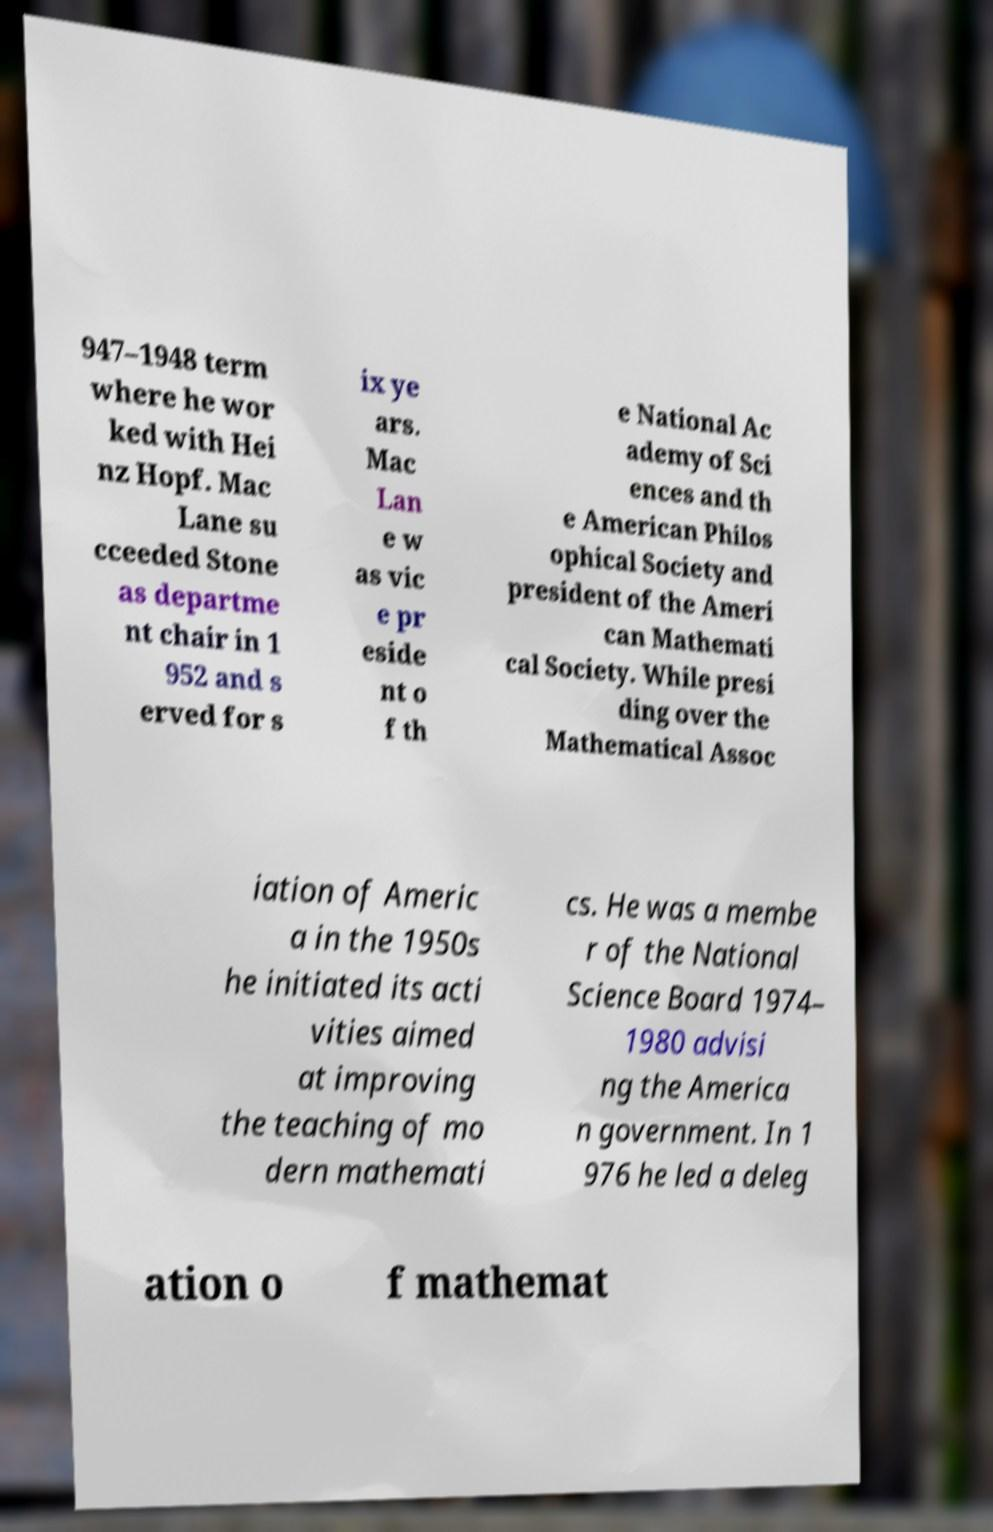There's text embedded in this image that I need extracted. Can you transcribe it verbatim? 947–1948 term where he wor ked with Hei nz Hopf. Mac Lane su cceeded Stone as departme nt chair in 1 952 and s erved for s ix ye ars. Mac Lan e w as vic e pr eside nt o f th e National Ac ademy of Sci ences and th e American Philos ophical Society and president of the Ameri can Mathemati cal Society. While presi ding over the Mathematical Assoc iation of Americ a in the 1950s he initiated its acti vities aimed at improving the teaching of mo dern mathemati cs. He was a membe r of the National Science Board 1974– 1980 advisi ng the America n government. In 1 976 he led a deleg ation o f mathemat 